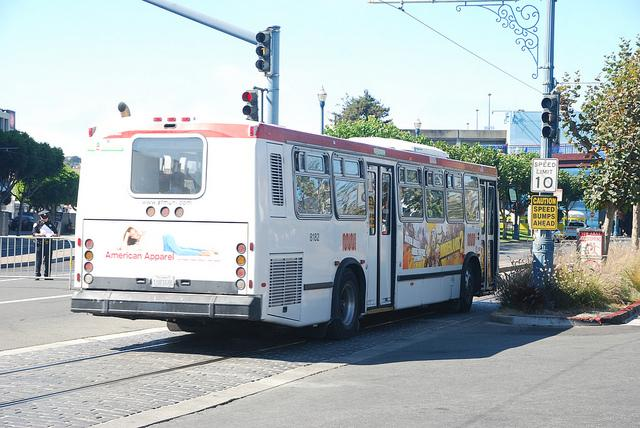Where is the bus located?

Choices:
A) bus lane
B) crosswalk
C) bike path
D) dog path bus lane 